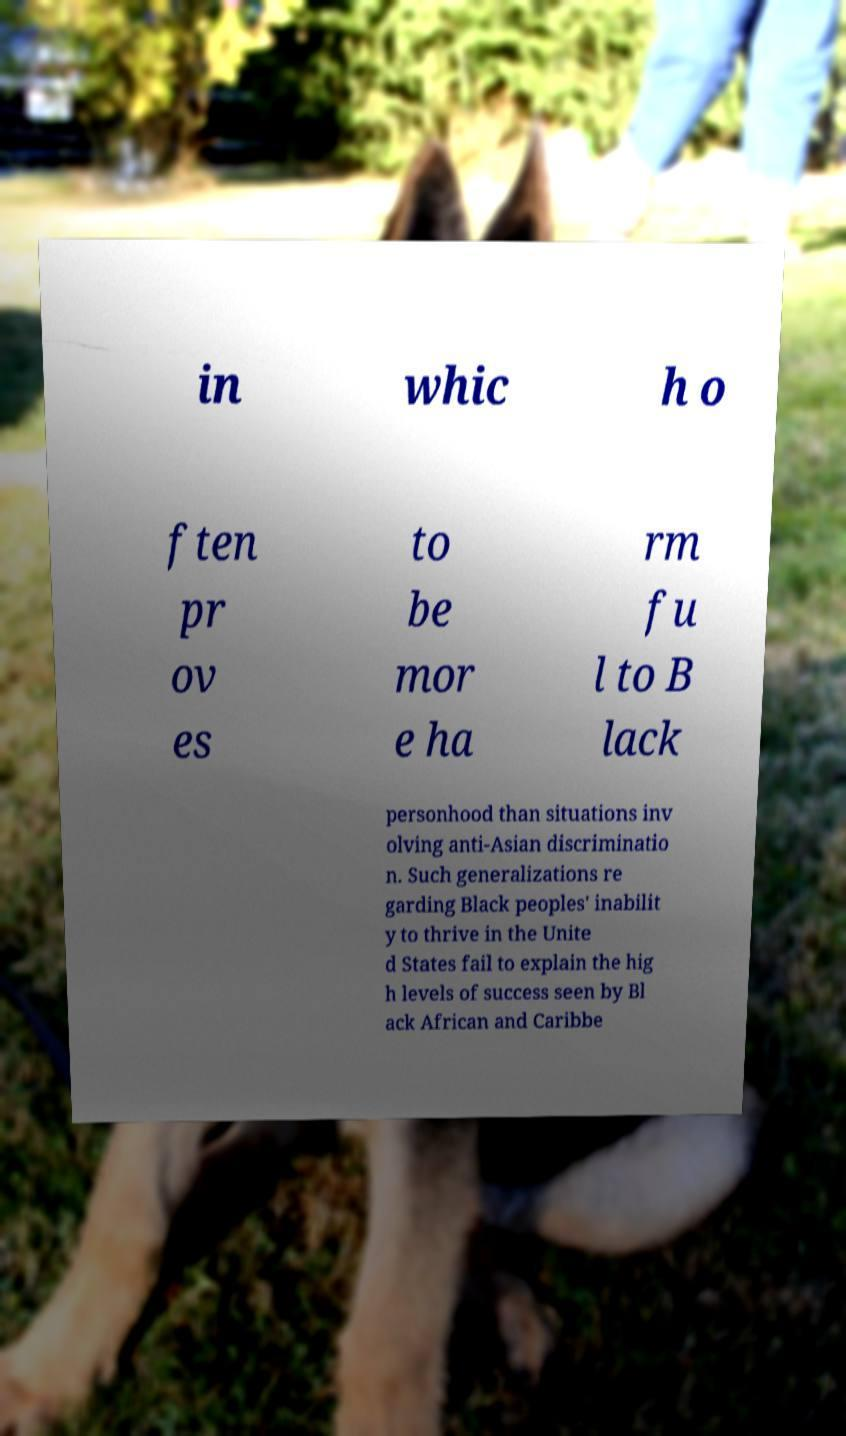I need the written content from this picture converted into text. Can you do that? in whic h o ften pr ov es to be mor e ha rm fu l to B lack personhood than situations inv olving anti-Asian discriminatio n. Such generalizations re garding Black peoples' inabilit y to thrive in the Unite d States fail to explain the hig h levels of success seen by Bl ack African and Caribbe 